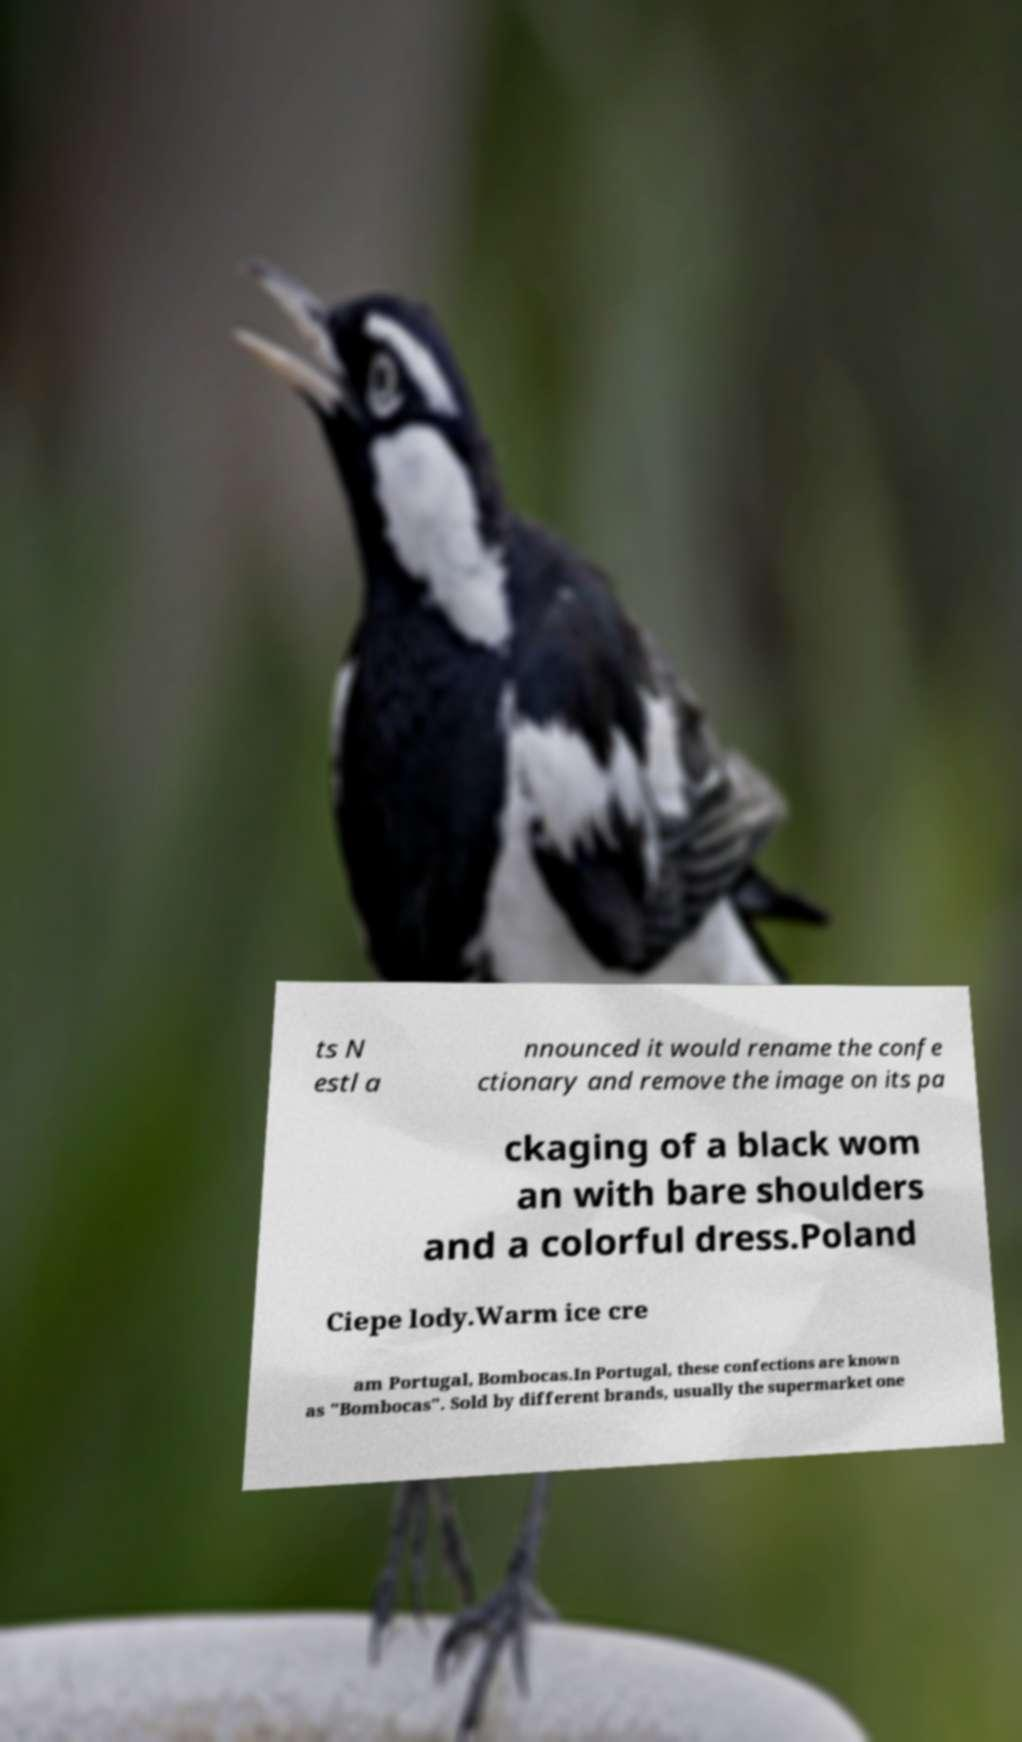Please read and relay the text visible in this image. What does it say? ts N estl a nnounced it would rename the confe ctionary and remove the image on its pa ckaging of a black wom an with bare shoulders and a colorful dress.Poland Ciepe lody.Warm ice cre am Portugal, Bombocas.In Portugal, these confections are known as "Bombocas". Sold by different brands, usually the supermarket one 